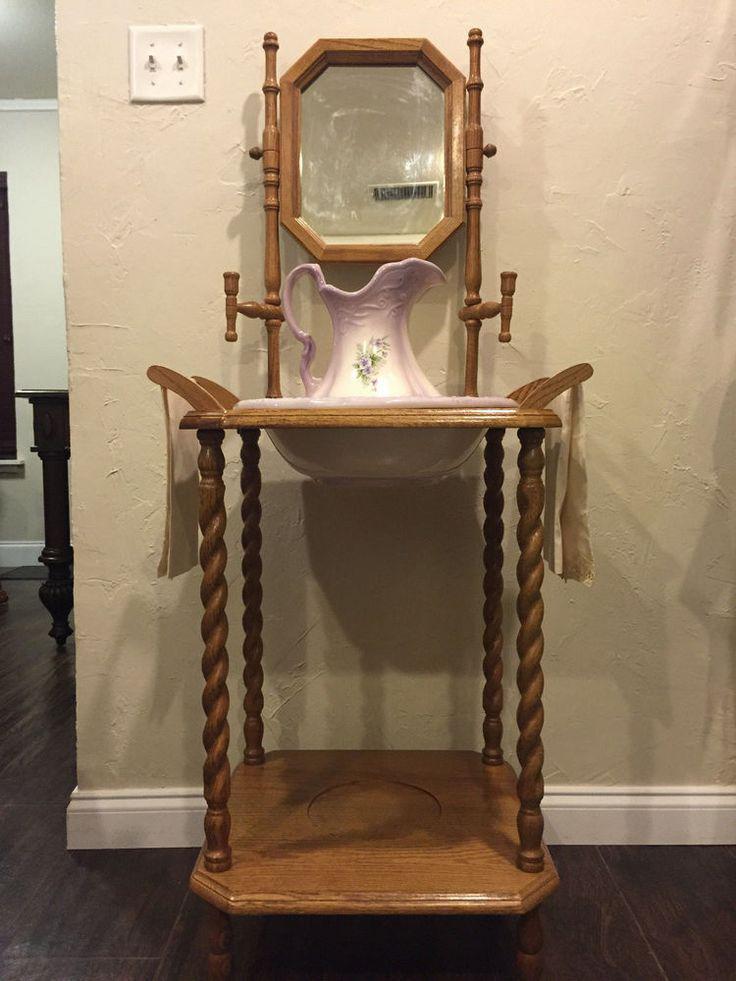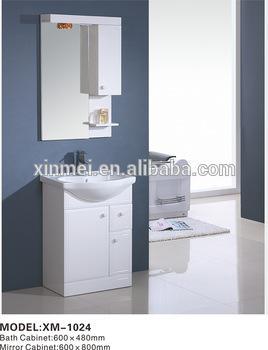The first image is the image on the left, the second image is the image on the right. Considering the images on both sides, is "One of the images shows a basin with no faucet." valid? Answer yes or no. Yes. The first image is the image on the left, the second image is the image on the right. For the images displayed, is the sentence "Photo contains single white sink." factually correct? Answer yes or no. Yes. 